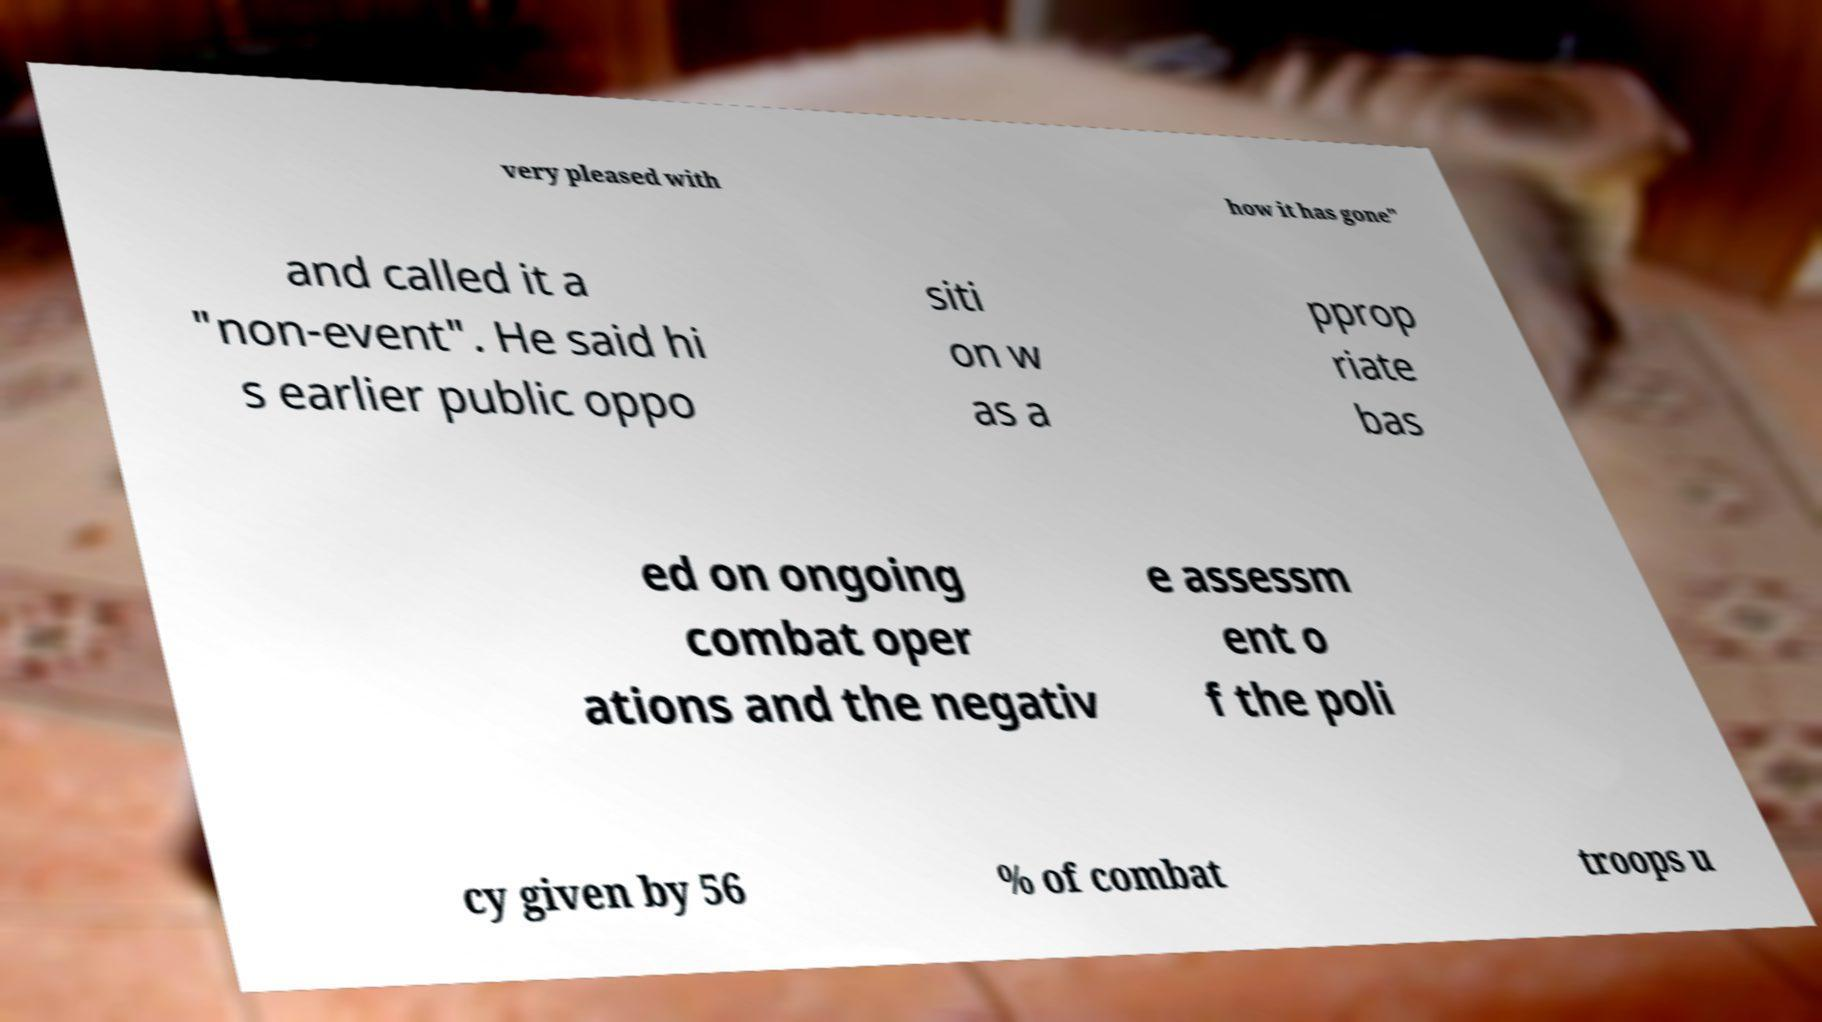Please identify and transcribe the text found in this image. very pleased with how it has gone" and called it a "non-event". He said hi s earlier public oppo siti on w as a pprop riate bas ed on ongoing combat oper ations and the negativ e assessm ent o f the poli cy given by 56 % of combat troops u 